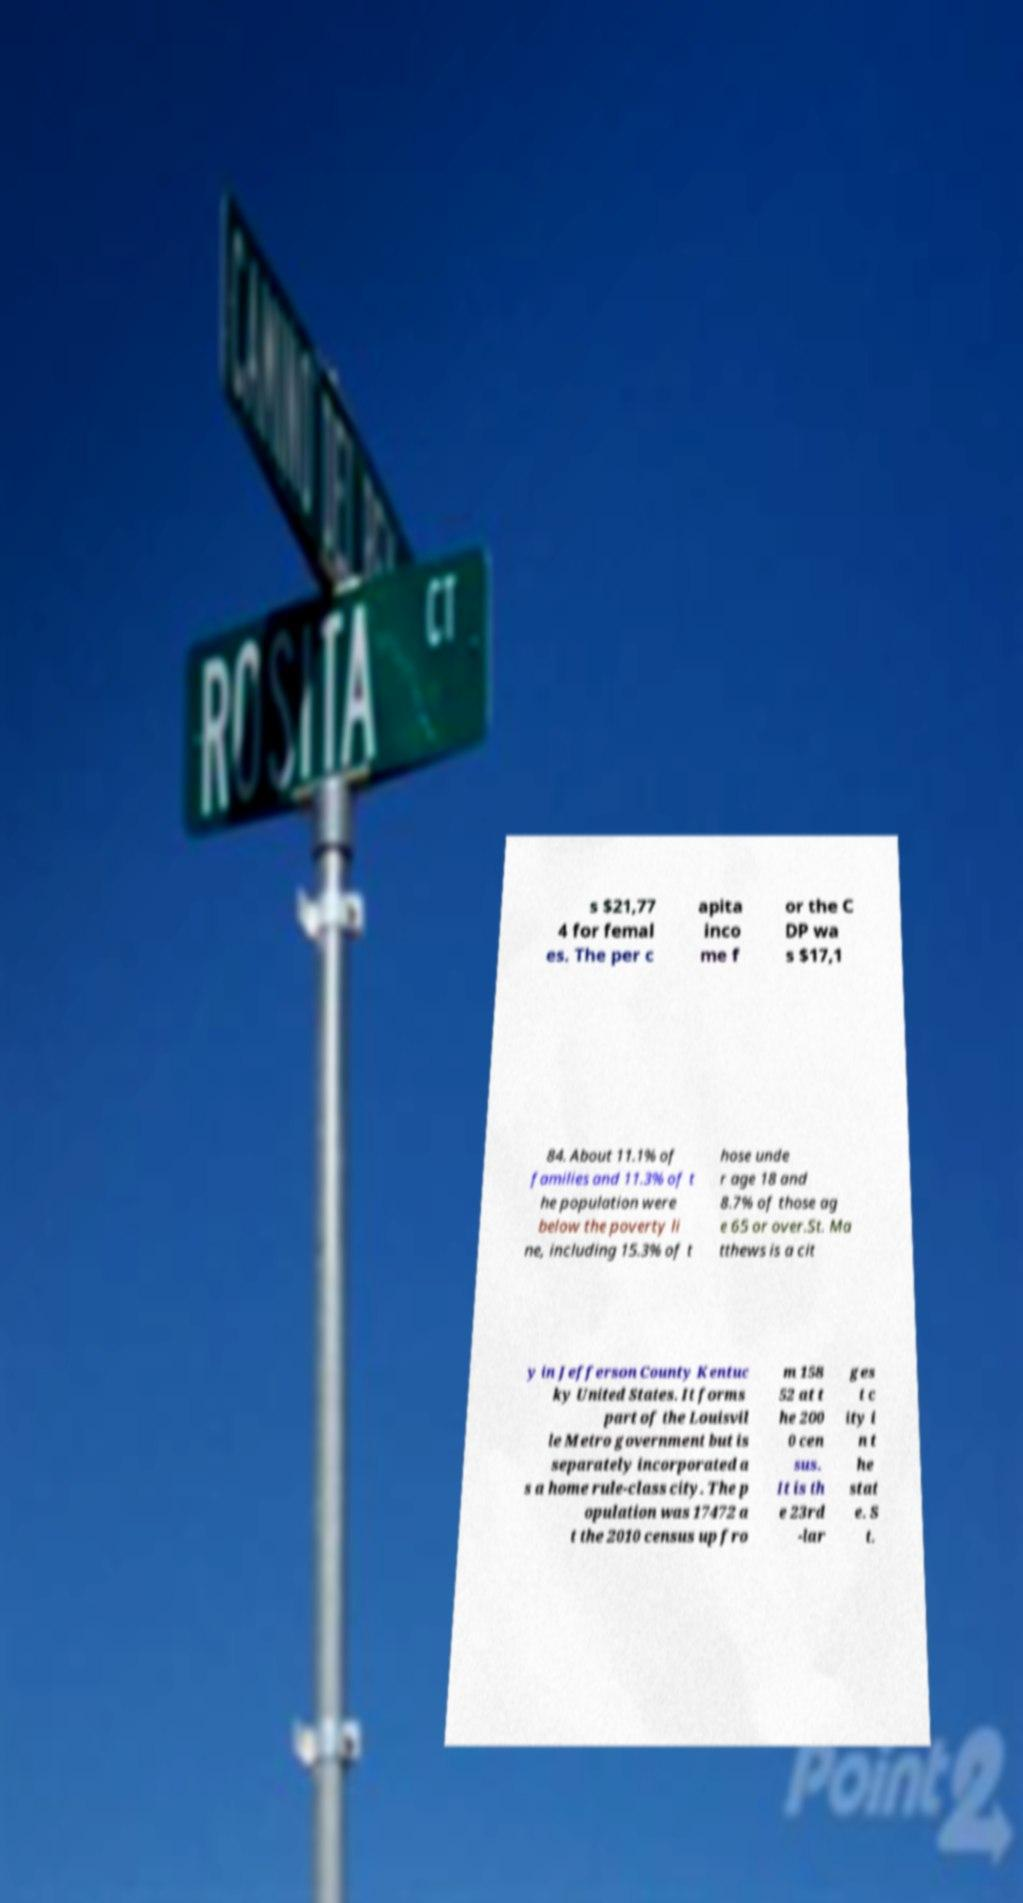I need the written content from this picture converted into text. Can you do that? s $21,77 4 for femal es. The per c apita inco me f or the C DP wa s $17,1 84. About 11.1% of families and 11.3% of t he population were below the poverty li ne, including 15.3% of t hose unde r age 18 and 8.7% of those ag e 65 or over.St. Ma tthews is a cit y in Jefferson County Kentuc ky United States. It forms part of the Louisvil le Metro government but is separately incorporated a s a home rule-class city. The p opulation was 17472 a t the 2010 census up fro m 158 52 at t he 200 0 cen sus. It is th e 23rd -lar ges t c ity i n t he stat e. S t. 